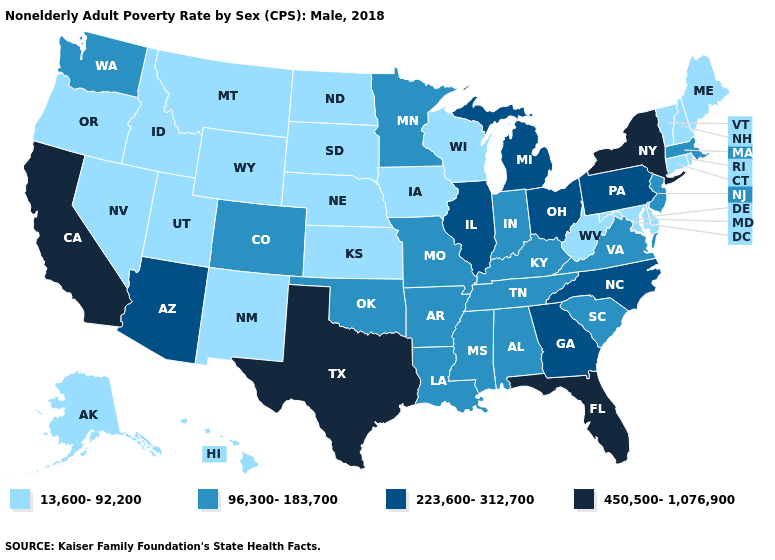Does California have the highest value in the USA?
Give a very brief answer. Yes. Does North Dakota have a higher value than Kansas?
Give a very brief answer. No. Among the states that border New York , does New Jersey have the highest value?
Give a very brief answer. No. Does South Dakota have the lowest value in the USA?
Concise answer only. Yes. Name the states that have a value in the range 13,600-92,200?
Short answer required. Alaska, Connecticut, Delaware, Hawaii, Idaho, Iowa, Kansas, Maine, Maryland, Montana, Nebraska, Nevada, New Hampshire, New Mexico, North Dakota, Oregon, Rhode Island, South Dakota, Utah, Vermont, West Virginia, Wisconsin, Wyoming. Does New Hampshire have the highest value in the Northeast?
Write a very short answer. No. Name the states that have a value in the range 450,500-1,076,900?
Short answer required. California, Florida, New York, Texas. Does Nebraska have a higher value than Ohio?
Keep it brief. No. How many symbols are there in the legend?
Be succinct. 4. What is the value of New Jersey?
Write a very short answer. 96,300-183,700. How many symbols are there in the legend?
Give a very brief answer. 4. What is the highest value in the South ?
Be succinct. 450,500-1,076,900. Does Utah have the highest value in the West?
Concise answer only. No. Does Indiana have the lowest value in the MidWest?
Answer briefly. No. 